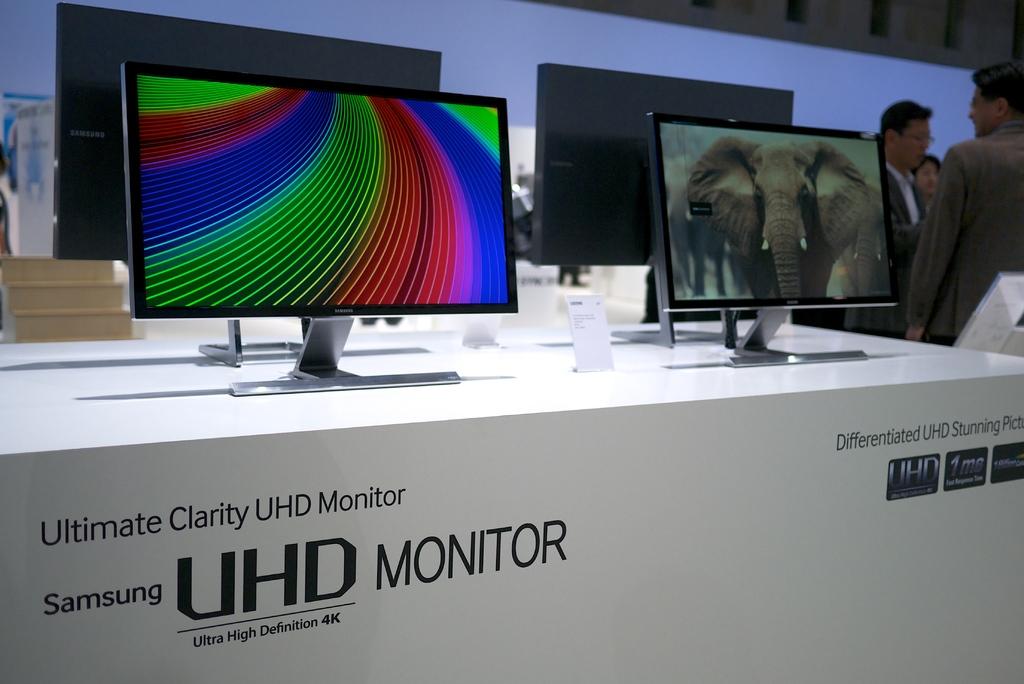What brand is this tv?
Your response must be concise. Samsung. What type of monitor is this?
Your response must be concise. Samsung uhd monitor. 